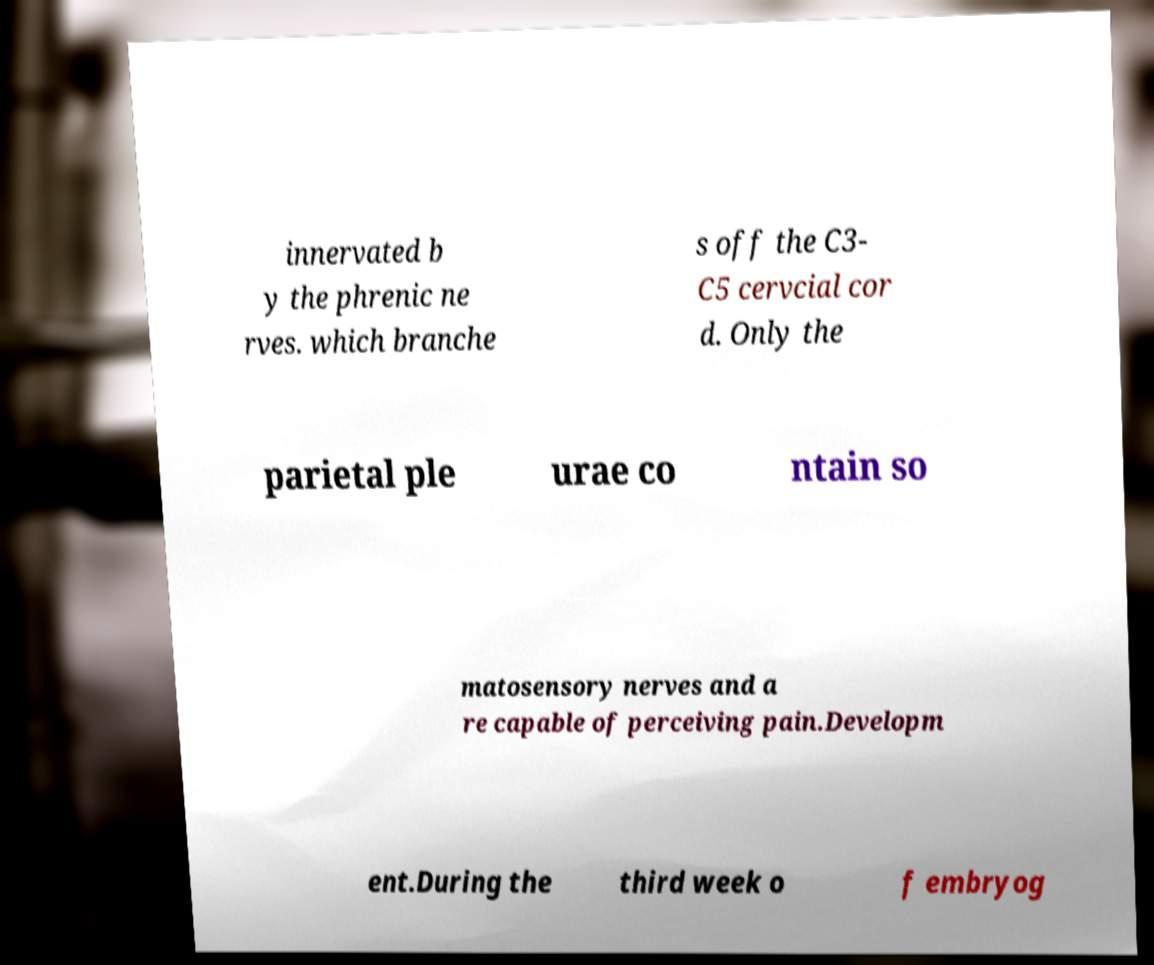Can you accurately transcribe the text from the provided image for me? innervated b y the phrenic ne rves. which branche s off the C3- C5 cervcial cor d. Only the parietal ple urae co ntain so matosensory nerves and a re capable of perceiving pain.Developm ent.During the third week o f embryog 